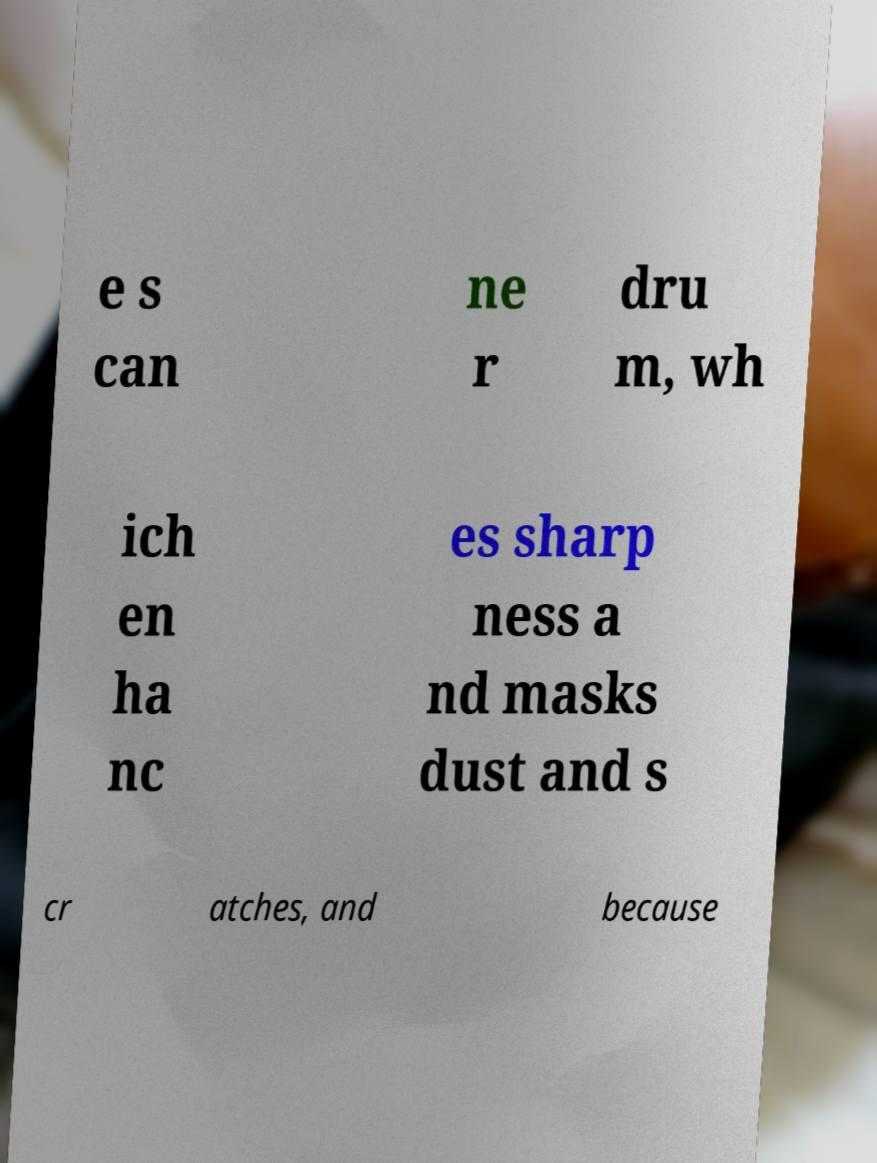For documentation purposes, I need the text within this image transcribed. Could you provide that? e s can ne r dru m, wh ich en ha nc es sharp ness a nd masks dust and s cr atches, and because 